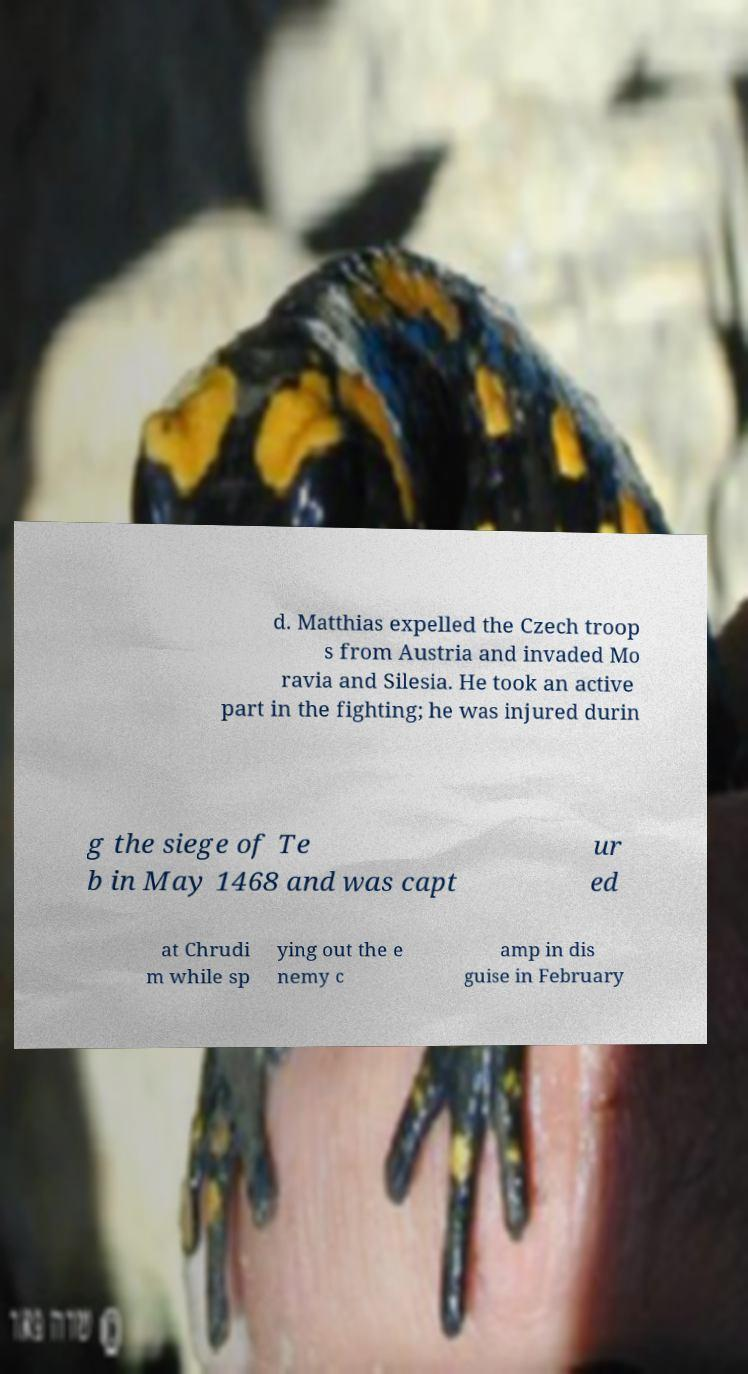Could you extract and type out the text from this image? d. Matthias expelled the Czech troop s from Austria and invaded Mo ravia and Silesia. He took an active part in the fighting; he was injured durin g the siege of Te b in May 1468 and was capt ur ed at Chrudi m while sp ying out the e nemy c amp in dis guise in February 